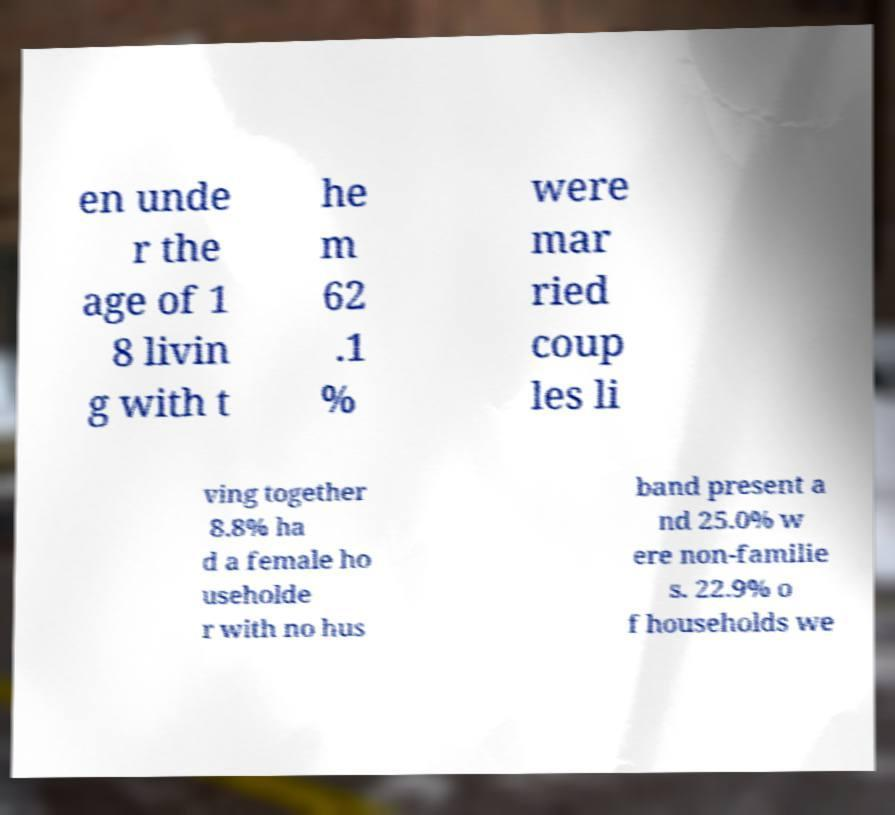Can you accurately transcribe the text from the provided image for me? en unde r the age of 1 8 livin g with t he m 62 .1 % were mar ried coup les li ving together 8.8% ha d a female ho useholde r with no hus band present a nd 25.0% w ere non-familie s. 22.9% o f households we 